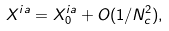Convert formula to latex. <formula><loc_0><loc_0><loc_500><loc_500>X ^ { i a } = X ^ { i a } _ { 0 } + O ( 1 / N _ { c } ^ { 2 } ) ,</formula> 